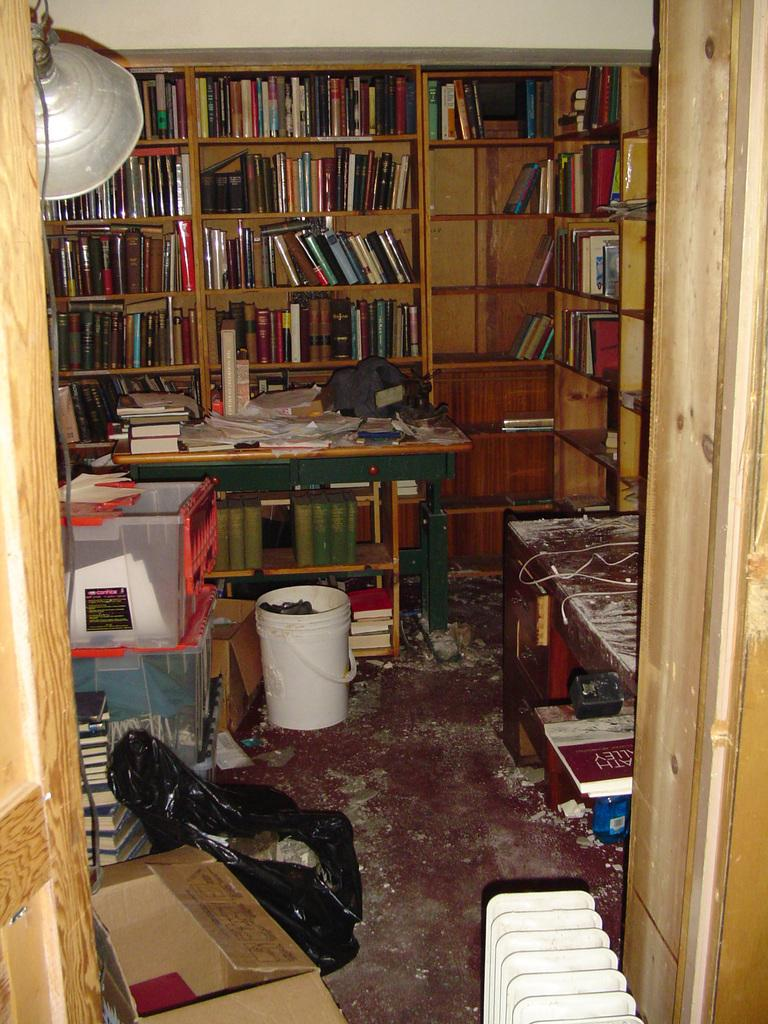What type of furniture is present in the image? There is a bookshelf and a table in the image. What is stored on the bookshelf? The bookshelf contains books. What other object can be seen in the image? There is a bucket in the image. Is there any covering or protection visible in the image? Yes, there is a cover in the image. What type of owl can be seen perched on the bookshelf in the image? There is no owl present in the image; it only features a bookshelf, table, bucket, and cover. 